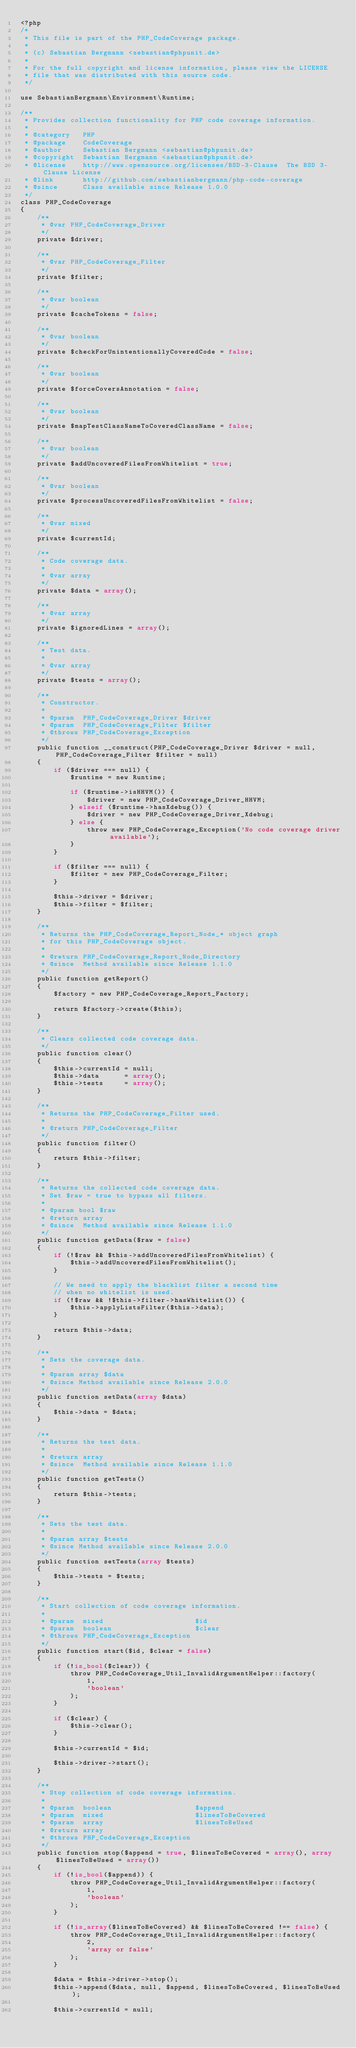Convert code to text. <code><loc_0><loc_0><loc_500><loc_500><_PHP_><?php
/*
 * This file is part of the PHP_CodeCoverage package.
 *
 * (c) Sebastian Bergmann <sebastian@phpunit.de>
 *
 * For the full copyright and license information, please view the LICENSE
 * file that was distributed with this source code.
 */

use SebastianBergmann\Environment\Runtime;

/**
 * Provides collection functionality for PHP code coverage information.
 *
 * @category   PHP
 * @package    CodeCoverage
 * @author     Sebastian Bergmann <sebastian@phpunit.de>
 * @copyright  Sebastian Bergmann <sebastian@phpunit.de>
 * @license    http://www.opensource.org/licenses/BSD-3-Clause  The BSD 3-Clause License
 * @link       http://github.com/sebastianbergmann/php-code-coverage
 * @since      Class available since Release 1.0.0
 */
class PHP_CodeCoverage
{
    /**
     * @var PHP_CodeCoverage_Driver
     */
    private $driver;

    /**
     * @var PHP_CodeCoverage_Filter
     */
    private $filter;

    /**
     * @var boolean
     */
    private $cacheTokens = false;

    /**
     * @var boolean
     */
    private $checkForUnintentionallyCoveredCode = false;

    /**
     * @var boolean
     */
    private $forceCoversAnnotation = false;

    /**
     * @var boolean
     */
    private $mapTestClassNameToCoveredClassName = false;

    /**
     * @var boolean
     */
    private $addUncoveredFilesFromWhitelist = true;

    /**
     * @var boolean
     */
    private $processUncoveredFilesFromWhitelist = false;

    /**
     * @var mixed
     */
    private $currentId;

    /**
     * Code coverage data.
     *
     * @var array
     */
    private $data = array();

    /**
     * @var array
     */
    private $ignoredLines = array();

    /**
     * Test data.
     *
     * @var array
     */
    private $tests = array();

    /**
     * Constructor.
     *
     * @param  PHP_CodeCoverage_Driver $driver
     * @param  PHP_CodeCoverage_Filter $filter
     * @throws PHP_CodeCoverage_Exception
     */
    public function __construct(PHP_CodeCoverage_Driver $driver = null, PHP_CodeCoverage_Filter $filter = null)
    {
        if ($driver === null) {
            $runtime = new Runtime;

            if ($runtime->isHHVM()) {
                $driver = new PHP_CodeCoverage_Driver_HHVM;
            } elseif ($runtime->hasXdebug()) {
                $driver = new PHP_CodeCoverage_Driver_Xdebug;
            } else {
                throw new PHP_CodeCoverage_Exception('No code coverage driver available');
            }
        }

        if ($filter === null) {
            $filter = new PHP_CodeCoverage_Filter;
        }

        $this->driver = $driver;
        $this->filter = $filter;
    }

    /**
     * Returns the PHP_CodeCoverage_Report_Node_* object graph
     * for this PHP_CodeCoverage object.
     *
     * @return PHP_CodeCoverage_Report_Node_Directory
     * @since  Method available since Release 1.1.0
     */
    public function getReport()
    {
        $factory = new PHP_CodeCoverage_Report_Factory;

        return $factory->create($this);
    }

    /**
     * Clears collected code coverage data.
     */
    public function clear()
    {
        $this->currentId = null;
        $this->data      = array();
        $this->tests     = array();
    }

    /**
     * Returns the PHP_CodeCoverage_Filter used.
     *
     * @return PHP_CodeCoverage_Filter
     */
    public function filter()
    {
        return $this->filter;
    }

    /**
     * Returns the collected code coverage data.
     * Set $raw = true to bypass all filters.
     *
     * @param bool $raw
     * @return array
     * @since  Method available since Release 1.1.0
     */
    public function getData($raw = false)
    {
        if (!$raw && $this->addUncoveredFilesFromWhitelist) {
            $this->addUncoveredFilesFromWhitelist();
        }

        // We need to apply the blacklist filter a second time
        // when no whitelist is used.
        if (!$raw && !$this->filter->hasWhitelist()) {
            $this->applyListsFilter($this->data);
        }

        return $this->data;
    }

    /**
     * Sets the coverage data.
     *
     * @param array $data
     * @since Method available since Release 2.0.0
     */
    public function setData(array $data)
    {
        $this->data = $data;
    }

    /**
     * Returns the test data.
     *
     * @return array
     * @since  Method available since Release 1.1.0
     */
    public function getTests()
    {
        return $this->tests;
    }

    /**
     * Sets the test data.
     *
     * @param array $tests
     * @since Method available since Release 2.0.0
     */
    public function setTests(array $tests)
    {
        $this->tests = $tests;
    }

    /**
     * Start collection of code coverage information.
     *
     * @param  mixed                      $id
     * @param  boolean                    $clear
     * @throws PHP_CodeCoverage_Exception
     */
    public function start($id, $clear = false)
    {
        if (!is_bool($clear)) {
            throw PHP_CodeCoverage_Util_InvalidArgumentHelper::factory(
                1,
                'boolean'
            );
        }

        if ($clear) {
            $this->clear();
        }

        $this->currentId = $id;

        $this->driver->start();
    }

    /**
     * Stop collection of code coverage information.
     *
     * @param  boolean                    $append
     * @param  mixed                      $linesToBeCovered
     * @param  array                      $linesToBeUsed
     * @return array
     * @throws PHP_CodeCoverage_Exception
     */
    public function stop($append = true, $linesToBeCovered = array(), array $linesToBeUsed = array())
    {
        if (!is_bool($append)) {
            throw PHP_CodeCoverage_Util_InvalidArgumentHelper::factory(
                1,
                'boolean'
            );
        }

        if (!is_array($linesToBeCovered) && $linesToBeCovered !== false) {
            throw PHP_CodeCoverage_Util_InvalidArgumentHelper::factory(
                2,
                'array or false'
            );
        }

        $data = $this->driver->stop();
        $this->append($data, null, $append, $linesToBeCovered, $linesToBeUsed);

        $this->currentId = null;
</code> 